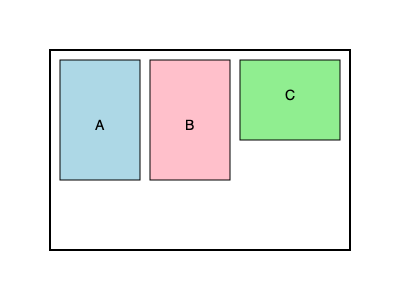Your child's suitcases need to be packed into the car trunk for their journey to Latvia. The trunk is represented by the outer rectangle, and the suitcases are labeled A, B, and C. If suitcase C can be rotated 90 degrees, in how many different ways can you arrange all three suitcases to fit in the trunk without overlapping? Let's approach this step-by-step, keeping in mind the emotional significance of packing for your child's journey:

1. First, observe the dimensions:
   - Trunk: 300 units wide, 200 units tall
   - Suitcase A: 80 x 120
   - Suitcase B: 80 x 120
   - Suitcase C: 100 x 80 (can be rotated to 80 x 100)

2. Consider the possible arrangements:
   a) A and B side by side (160 units wide), C on the right:
      - C vertical: Fits (160 + 100 = 260 < 300)
      - C horizontal: Fits (160 + 80 = 240 < 300)

   b) A and B side by side, C on top:
      - C horizontal: Fits (300 wide, 120 + 80 = 200 tall)

   c) A, B, and C all in a row:
      - C vertical: Doesn't fit (80 + 80 + 100 = 260 > 200 height)
      - C horizontal: Fits (80 + 80 + 80 = 240 < 300)

   d) A and C side by side, B on the right:
      - C vertical: Fits (80 + 100 + 80 = 260 < 300)
      - C horizontal: Doesn't fit (80 + 80 + 80 = 240 width, but 120 > 100 height)

   e) B and C side by side, A on the right:
      - Same as arrangement (d)

3. Count the valid arrangements:
   - (a) with C vertical
   - (a) with C horizontal
   - (b) with C horizontal
   - (c) with C horizontal
   - (d) with C vertical

Therefore, there are 5 different ways to arrange the suitcases.
Answer: 5 ways 